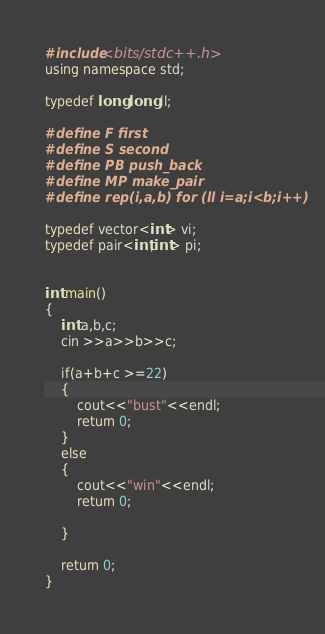Convert code to text. <code><loc_0><loc_0><loc_500><loc_500><_C++_>#include<bits/stdc++.h>
using namespace std;

typedef long long ll;

#define F first 
#define S second 
#define PB push_back
#define MP make_pair 
#define rep(i,a,b) for (ll i=a;i<b;i++)

typedef vector<int> vi;
typedef pair<int,int> pi;


int main()
{
    int a,b,c;
    cin >>a>>b>>c;

    if(a+b+c >=22)
    {
        cout<<"bust"<<endl;
        return 0; 
    }
    else
    {
        cout<<"win"<<endl;
        return 0; 

    }

    return 0; 
}

</code> 